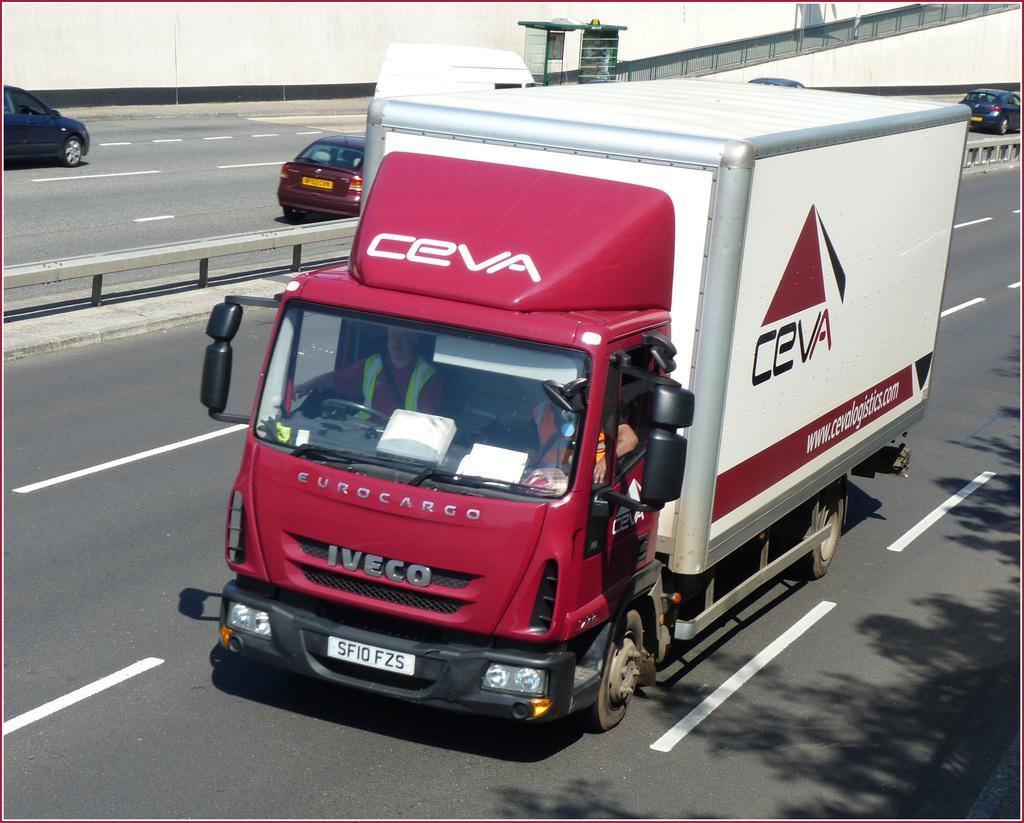Could you give a brief overview of what you see in this image? In the image I can see vehicles on the road among them the truck in front of the image has a logo and something written on it. I can also see white color lines on the road and some other objects in the background. 